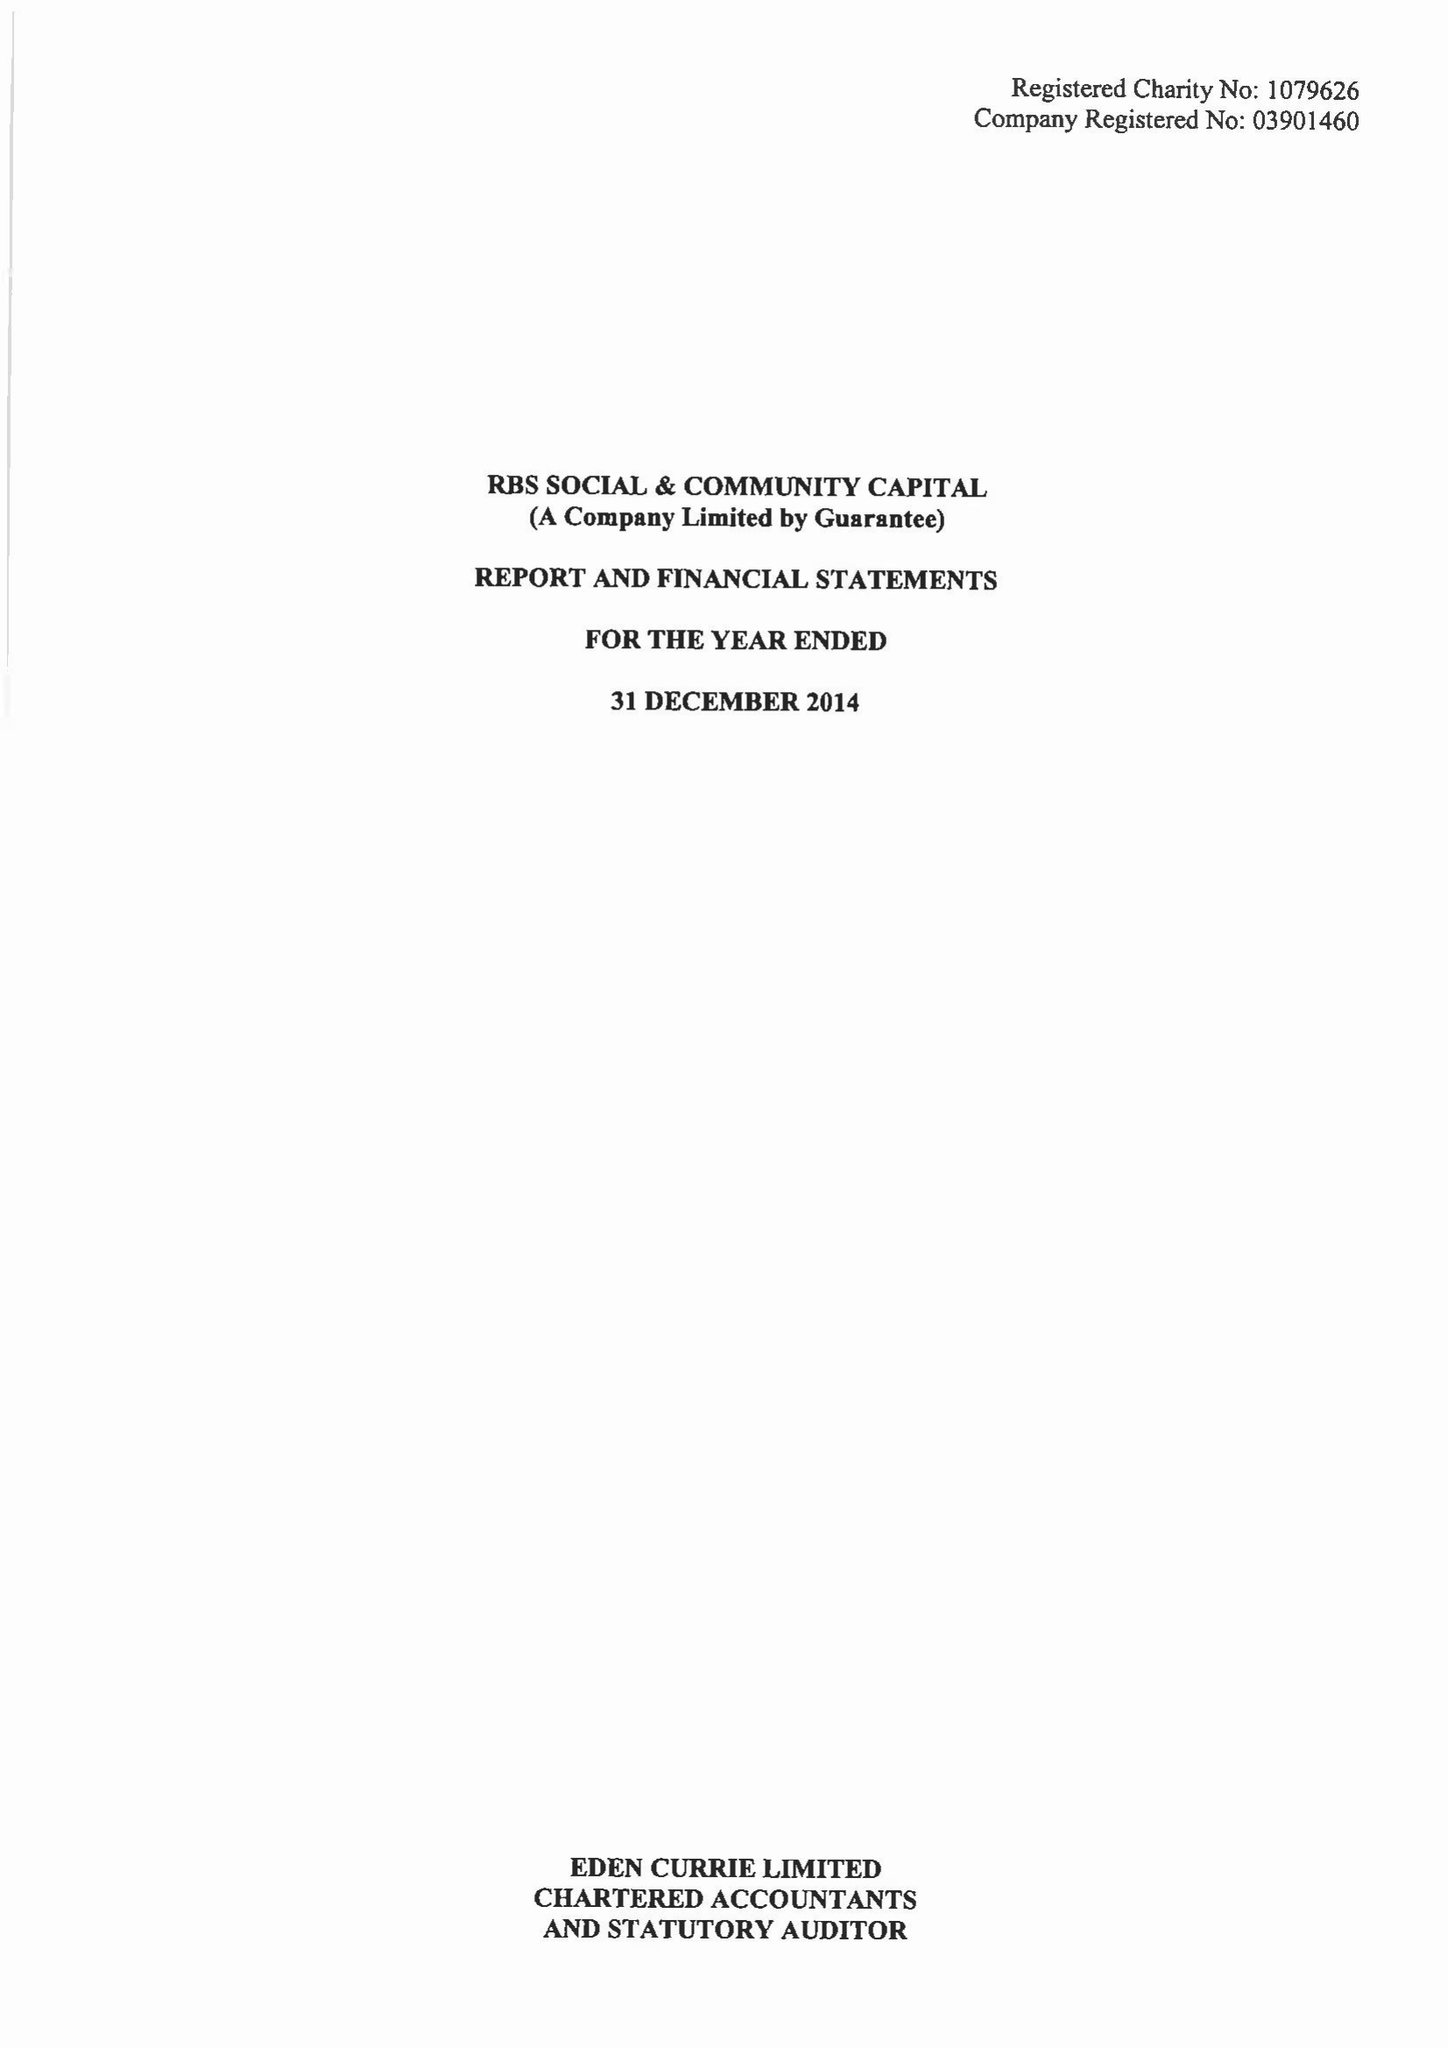What is the value for the charity_name?
Answer the question using a single word or phrase. Rbs Social and Community Capital 